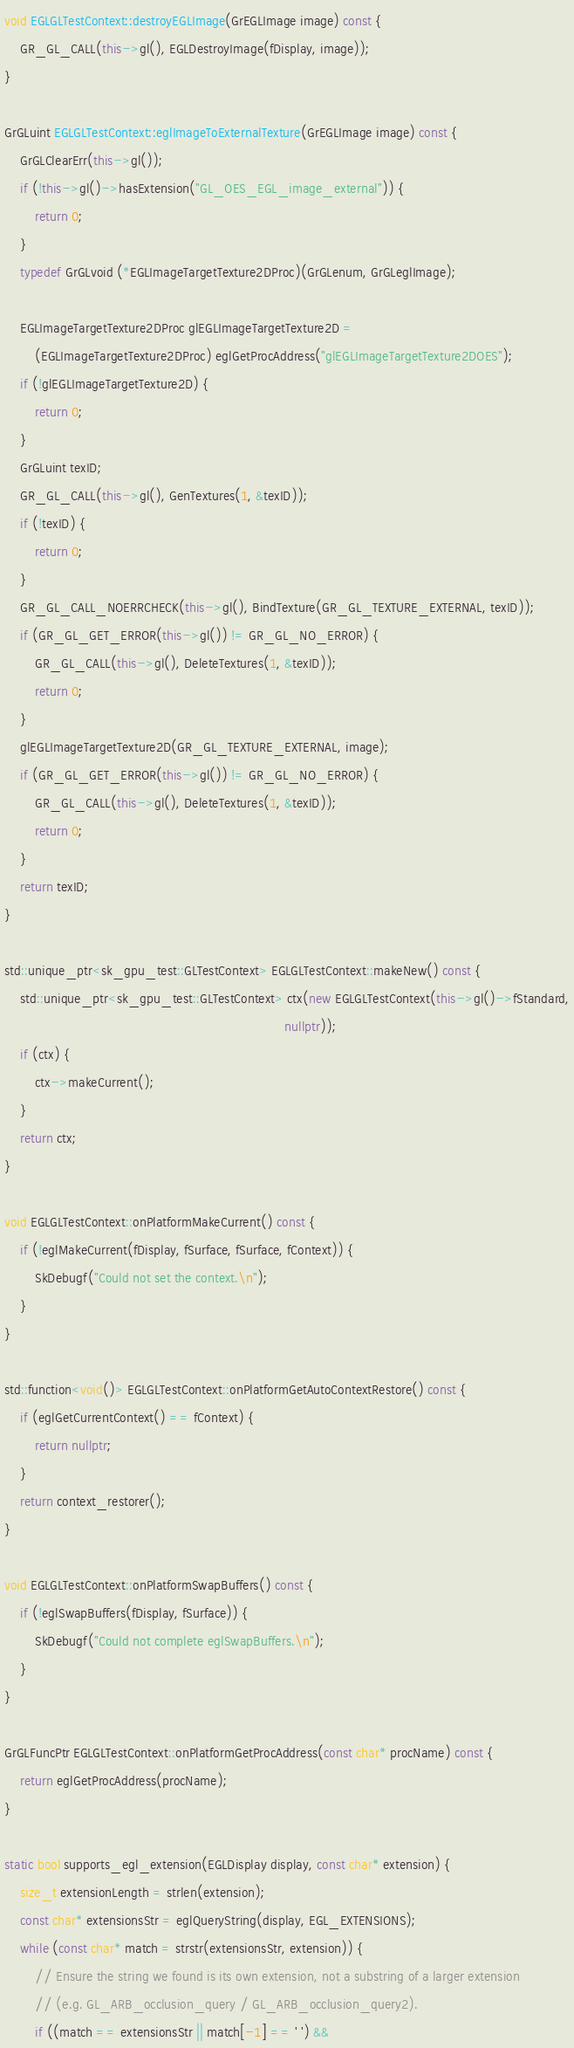<code> <loc_0><loc_0><loc_500><loc_500><_C++_>void EGLGLTestContext::destroyEGLImage(GrEGLImage image) const {
    GR_GL_CALL(this->gl(), EGLDestroyImage(fDisplay, image));
}

GrGLuint EGLGLTestContext::eglImageToExternalTexture(GrEGLImage image) const {
    GrGLClearErr(this->gl());
    if (!this->gl()->hasExtension("GL_OES_EGL_image_external")) {
        return 0;
    }
    typedef GrGLvoid (*EGLImageTargetTexture2DProc)(GrGLenum, GrGLeglImage);

    EGLImageTargetTexture2DProc glEGLImageTargetTexture2D =
        (EGLImageTargetTexture2DProc) eglGetProcAddress("glEGLImageTargetTexture2DOES");
    if (!glEGLImageTargetTexture2D) {
        return 0;
    }
    GrGLuint texID;
    GR_GL_CALL(this->gl(), GenTextures(1, &texID));
    if (!texID) {
        return 0;
    }
    GR_GL_CALL_NOERRCHECK(this->gl(), BindTexture(GR_GL_TEXTURE_EXTERNAL, texID));
    if (GR_GL_GET_ERROR(this->gl()) != GR_GL_NO_ERROR) {
        GR_GL_CALL(this->gl(), DeleteTextures(1, &texID));
        return 0;
    }
    glEGLImageTargetTexture2D(GR_GL_TEXTURE_EXTERNAL, image);
    if (GR_GL_GET_ERROR(this->gl()) != GR_GL_NO_ERROR) {
        GR_GL_CALL(this->gl(), DeleteTextures(1, &texID));
        return 0;
    }
    return texID;
}

std::unique_ptr<sk_gpu_test::GLTestContext> EGLGLTestContext::makeNew() const {
    std::unique_ptr<sk_gpu_test::GLTestContext> ctx(new EGLGLTestContext(this->gl()->fStandard,
                                                                         nullptr));
    if (ctx) {
        ctx->makeCurrent();
    }
    return ctx;
}

void EGLGLTestContext::onPlatformMakeCurrent() const {
    if (!eglMakeCurrent(fDisplay, fSurface, fSurface, fContext)) {
        SkDebugf("Could not set the context.\n");
    }
}

std::function<void()> EGLGLTestContext::onPlatformGetAutoContextRestore() const {
    if (eglGetCurrentContext() == fContext) {
        return nullptr;
    }
    return context_restorer();
}

void EGLGLTestContext::onPlatformSwapBuffers() const {
    if (!eglSwapBuffers(fDisplay, fSurface)) {
        SkDebugf("Could not complete eglSwapBuffers.\n");
    }
}

GrGLFuncPtr EGLGLTestContext::onPlatformGetProcAddress(const char* procName) const {
    return eglGetProcAddress(procName);
}

static bool supports_egl_extension(EGLDisplay display, const char* extension) {
    size_t extensionLength = strlen(extension);
    const char* extensionsStr = eglQueryString(display, EGL_EXTENSIONS);
    while (const char* match = strstr(extensionsStr, extension)) {
        // Ensure the string we found is its own extension, not a substring of a larger extension
        // (e.g. GL_ARB_occlusion_query / GL_ARB_occlusion_query2).
        if ((match == extensionsStr || match[-1] == ' ') &&</code> 